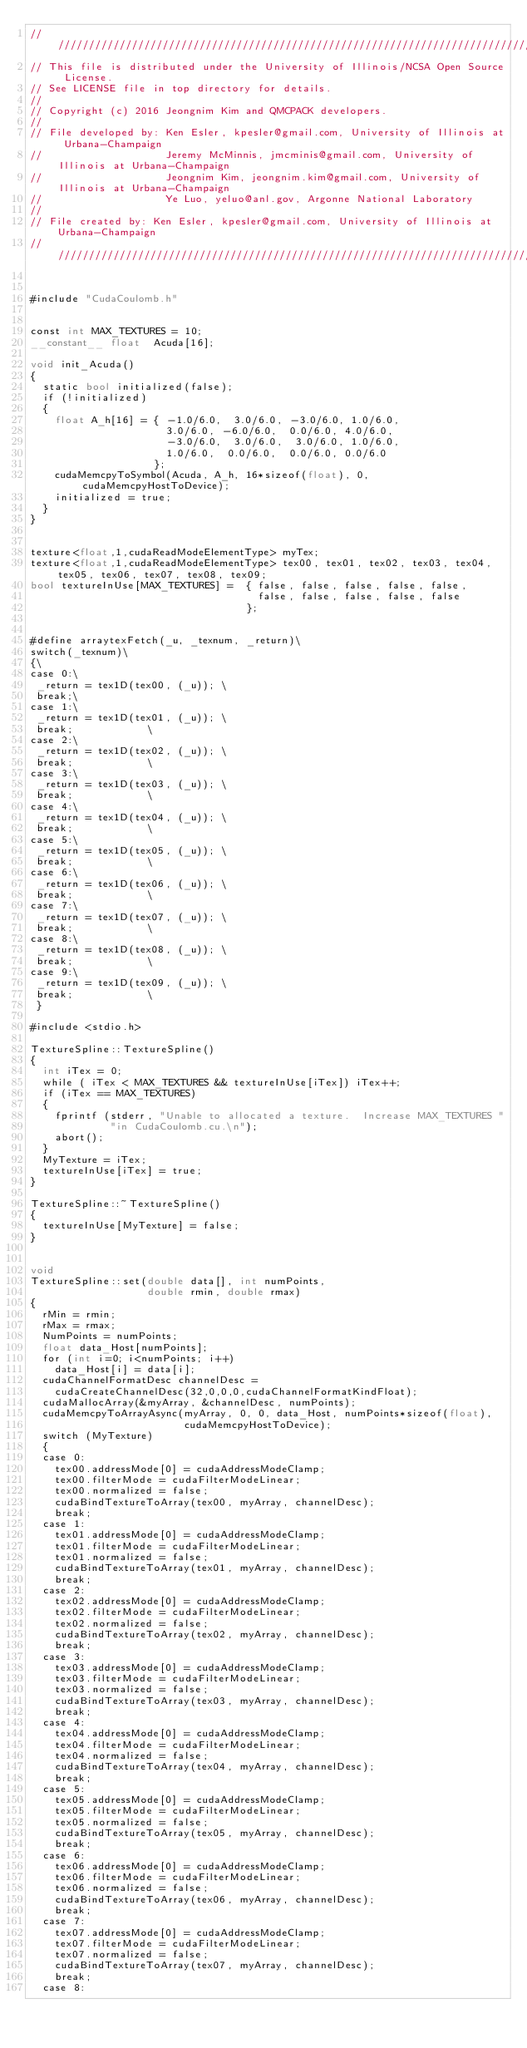<code> <loc_0><loc_0><loc_500><loc_500><_Cuda_>//////////////////////////////////////////////////////////////////////////////////////
// This file is distributed under the University of Illinois/NCSA Open Source License.
// See LICENSE file in top directory for details.
//
// Copyright (c) 2016 Jeongnim Kim and QMCPACK developers.
//
// File developed by: Ken Esler, kpesler@gmail.com, University of Illinois at Urbana-Champaign
//                    Jeremy McMinnis, jmcminis@gmail.com, University of Illinois at Urbana-Champaign
//                    Jeongnim Kim, jeongnim.kim@gmail.com, University of Illinois at Urbana-Champaign
//                    Ye Luo, yeluo@anl.gov, Argonne National Laboratory
//
// File created by: Ken Esler, kpesler@gmail.com, University of Illinois at Urbana-Champaign
//////////////////////////////////////////////////////////////////////////////////////
    
    
#include "CudaCoulomb.h"


const int MAX_TEXTURES = 10;
__constant__ float  Acuda[16];

void init_Acuda()
{
  static bool initialized(false);
  if (!initialized)
  {
    float A_h[16] = { -1.0/6.0,  3.0/6.0, -3.0/6.0, 1.0/6.0,
                      3.0/6.0, -6.0/6.0,  0.0/6.0, 4.0/6.0,
                      -3.0/6.0,  3.0/6.0,  3.0/6.0, 1.0/6.0,
                      1.0/6.0,  0.0/6.0,  0.0/6.0, 0.0/6.0
                    };
    cudaMemcpyToSymbol(Acuda, A_h, 16*sizeof(float), 0, cudaMemcpyHostToDevice);
    initialized = true;
  }
}


texture<float,1,cudaReadModeElementType> myTex;
texture<float,1,cudaReadModeElementType> tex00, tex01, tex02, tex03, tex04, tex05, tex06, tex07, tex08, tex09;
bool textureInUse[MAX_TEXTURES] =  { false, false, false, false, false,
                                     false, false, false, false, false
                                   };


#define arraytexFetch(_u, _texnum, _return)\
switch(_texnum)\
{\
case 0:\
 _return = tex1D(tex00, (_u)); \
 break;\
case 1:\
 _return = tex1D(tex01, (_u)); \
 break;			       \
case 2:\
 _return = tex1D(tex02, (_u)); \
 break;			       \
case 3:\
 _return = tex1D(tex03, (_u)); \
 break;			       \
case 4:\
 _return = tex1D(tex04, (_u)); \
 break;			       \
case 5:\
 _return = tex1D(tex05, (_u)); \
 break;			       \
case 6:\
 _return = tex1D(tex06, (_u)); \
 break;			       \
case 7:\
 _return = tex1D(tex07, (_u)); \
 break;			       \
case 8:\
 _return = tex1D(tex08, (_u)); \
 break;			       \
case 9:\
 _return = tex1D(tex09, (_u)); \
 break;			       \
 }

#include <stdio.h>

TextureSpline::TextureSpline()
{
  int iTex = 0;
  while ( iTex < MAX_TEXTURES && textureInUse[iTex]) iTex++;
  if (iTex == MAX_TEXTURES)
  {
    fprintf (stderr, "Unable to allocated a texture.  Increase MAX_TEXTURES "
             "in CudaCoulomb.cu.\n");
    abort();
  }
  MyTexture = iTex;
  textureInUse[iTex] = true;
}

TextureSpline::~TextureSpline()
{
  textureInUse[MyTexture] = false;
}


void
TextureSpline::set(double data[], int numPoints,
                   double rmin, double rmax)
{
  rMin = rmin;
  rMax = rmax;
  NumPoints = numPoints;
  float data_Host[numPoints];
  for (int i=0; i<numPoints; i++)
    data_Host[i] = data[i];
  cudaChannelFormatDesc channelDesc =
    cudaCreateChannelDesc(32,0,0,0,cudaChannelFormatKindFloat);
  cudaMallocArray(&myArray, &channelDesc, numPoints);
  cudaMemcpyToArrayAsync(myArray, 0, 0, data_Host, numPoints*sizeof(float),
                         cudaMemcpyHostToDevice);
  switch (MyTexture)
  {
  case 0:
    tex00.addressMode[0] = cudaAddressModeClamp;
    tex00.filterMode = cudaFilterModeLinear;
    tex00.normalized = false;
    cudaBindTextureToArray(tex00, myArray, channelDesc);
    break;
  case 1:
    tex01.addressMode[0] = cudaAddressModeClamp;
    tex01.filterMode = cudaFilterModeLinear;
    tex01.normalized = false;
    cudaBindTextureToArray(tex01, myArray, channelDesc);
    break;
  case 2:
    tex02.addressMode[0] = cudaAddressModeClamp;
    tex02.filterMode = cudaFilterModeLinear;
    tex02.normalized = false;
    cudaBindTextureToArray(tex02, myArray, channelDesc);
    break;
  case 3:
    tex03.addressMode[0] = cudaAddressModeClamp;
    tex03.filterMode = cudaFilterModeLinear;
    tex03.normalized = false;
    cudaBindTextureToArray(tex03, myArray, channelDesc);
    break;
  case 4:
    tex04.addressMode[0] = cudaAddressModeClamp;
    tex04.filterMode = cudaFilterModeLinear;
    tex04.normalized = false;
    cudaBindTextureToArray(tex04, myArray, channelDesc);
    break;
  case 5:
    tex05.addressMode[0] = cudaAddressModeClamp;
    tex05.filterMode = cudaFilterModeLinear;
    tex05.normalized = false;
    cudaBindTextureToArray(tex05, myArray, channelDesc);
    break;
  case 6:
    tex06.addressMode[0] = cudaAddressModeClamp;
    tex06.filterMode = cudaFilterModeLinear;
    tex06.normalized = false;
    cudaBindTextureToArray(tex06, myArray, channelDesc);
    break;
  case 7:
    tex07.addressMode[0] = cudaAddressModeClamp;
    tex07.filterMode = cudaFilterModeLinear;
    tex07.normalized = false;
    cudaBindTextureToArray(tex07, myArray, channelDesc);
    break;
  case 8:</code> 